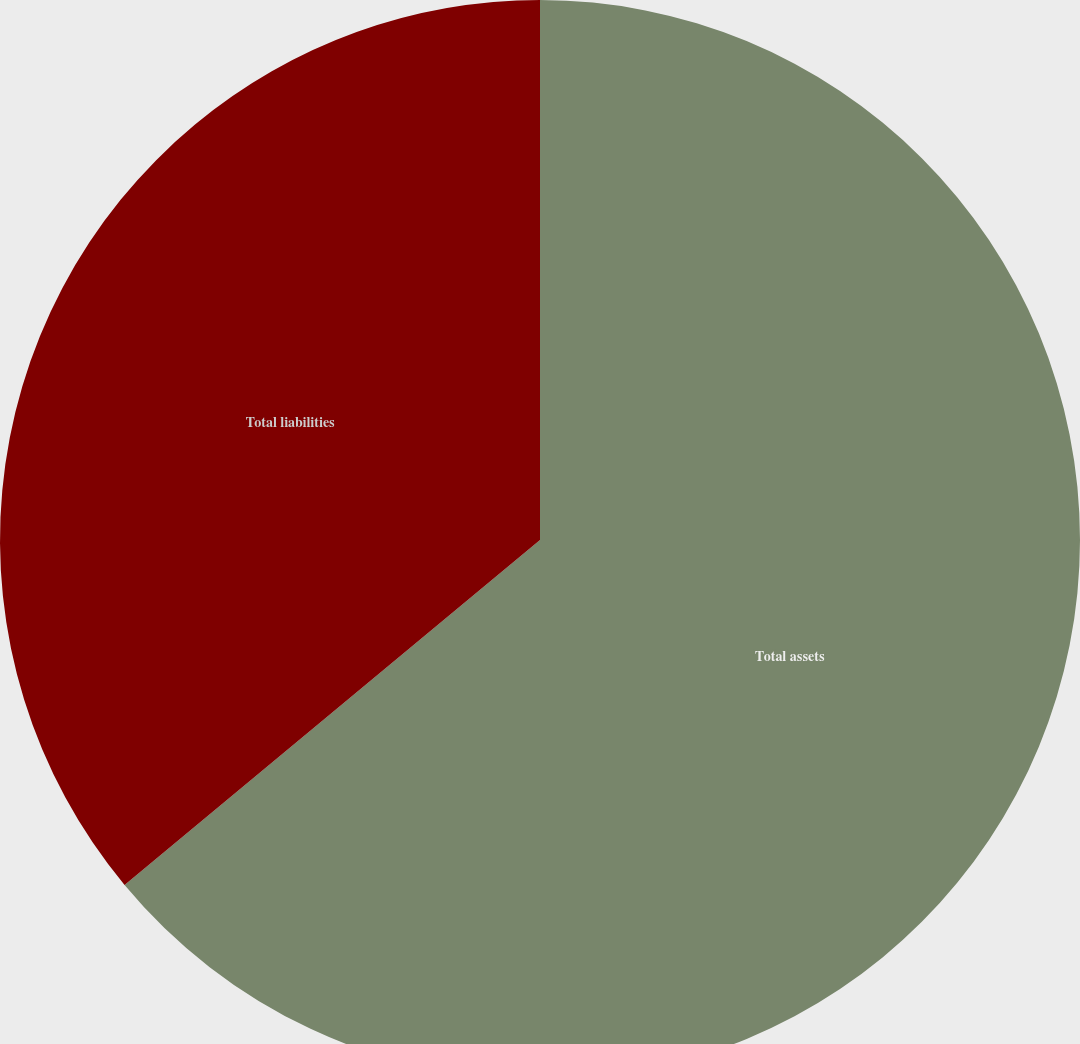Convert chart. <chart><loc_0><loc_0><loc_500><loc_500><pie_chart><fcel>Total assets<fcel>Total liabilities<nl><fcel>63.97%<fcel>36.03%<nl></chart> 